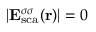Convert formula to latex. <formula><loc_0><loc_0><loc_500><loc_500>| { E } _ { s c a } ^ { \sigma \sigma } ( { r } ) | = 0</formula> 